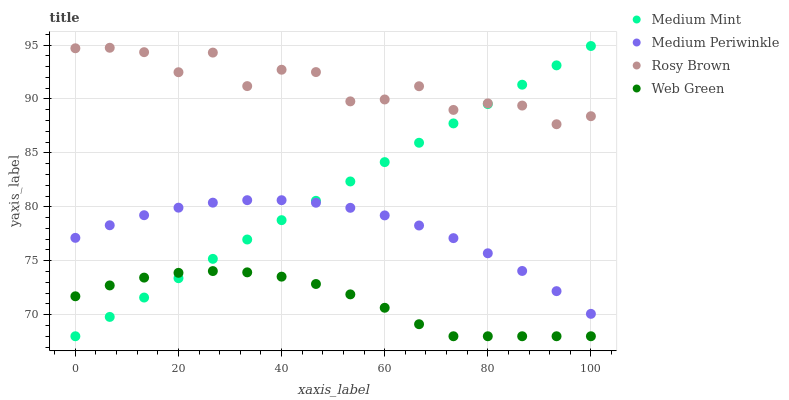Does Web Green have the minimum area under the curve?
Answer yes or no. Yes. Does Rosy Brown have the maximum area under the curve?
Answer yes or no. Yes. Does Medium Periwinkle have the minimum area under the curve?
Answer yes or no. No. Does Medium Periwinkle have the maximum area under the curve?
Answer yes or no. No. Is Medium Mint the smoothest?
Answer yes or no. Yes. Is Rosy Brown the roughest?
Answer yes or no. Yes. Is Medium Periwinkle the smoothest?
Answer yes or no. No. Is Medium Periwinkle the roughest?
Answer yes or no. No. Does Medium Mint have the lowest value?
Answer yes or no. Yes. Does Medium Periwinkle have the lowest value?
Answer yes or no. No. Does Medium Mint have the highest value?
Answer yes or no. Yes. Does Rosy Brown have the highest value?
Answer yes or no. No. Is Medium Periwinkle less than Rosy Brown?
Answer yes or no. Yes. Is Rosy Brown greater than Medium Periwinkle?
Answer yes or no. Yes. Does Medium Periwinkle intersect Medium Mint?
Answer yes or no. Yes. Is Medium Periwinkle less than Medium Mint?
Answer yes or no. No. Is Medium Periwinkle greater than Medium Mint?
Answer yes or no. No. Does Medium Periwinkle intersect Rosy Brown?
Answer yes or no. No. 